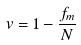<formula> <loc_0><loc_0><loc_500><loc_500>v = 1 - \frac { f _ { m } } { N }</formula> 